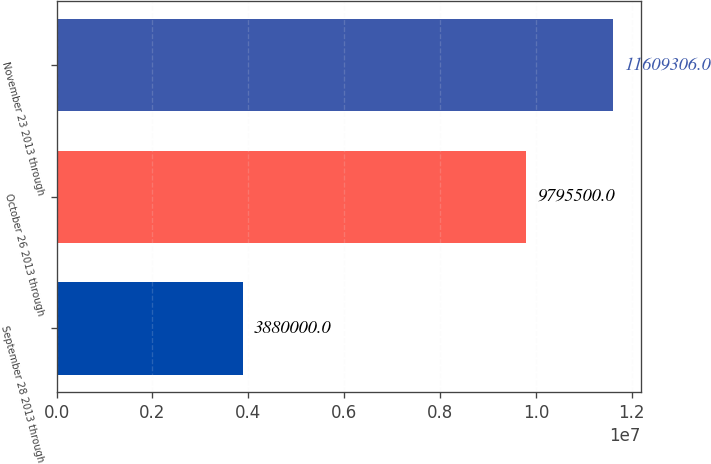Convert chart to OTSL. <chart><loc_0><loc_0><loc_500><loc_500><bar_chart><fcel>September 28 2013 through<fcel>October 26 2013 through<fcel>November 23 2013 through<nl><fcel>3.88e+06<fcel>9.7955e+06<fcel>1.16093e+07<nl></chart> 